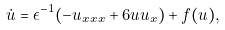Convert formula to latex. <formula><loc_0><loc_0><loc_500><loc_500>\dot { u } = \epsilon ^ { - 1 } ( - u _ { x x x } + 6 u u _ { x } ) + f ( u ) ,</formula> 